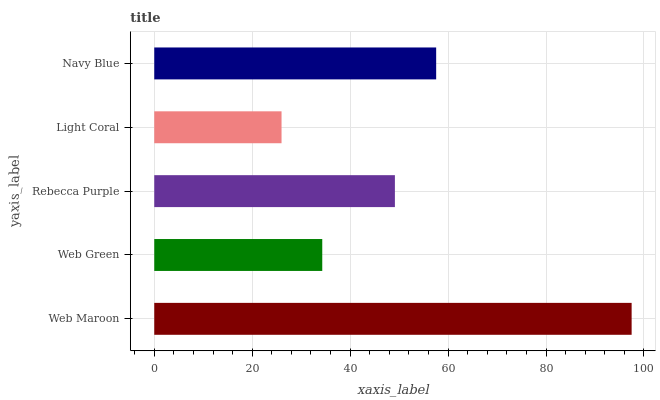Is Light Coral the minimum?
Answer yes or no. Yes. Is Web Maroon the maximum?
Answer yes or no. Yes. Is Web Green the minimum?
Answer yes or no. No. Is Web Green the maximum?
Answer yes or no. No. Is Web Maroon greater than Web Green?
Answer yes or no. Yes. Is Web Green less than Web Maroon?
Answer yes or no. Yes. Is Web Green greater than Web Maroon?
Answer yes or no. No. Is Web Maroon less than Web Green?
Answer yes or no. No. Is Rebecca Purple the high median?
Answer yes or no. Yes. Is Rebecca Purple the low median?
Answer yes or no. Yes. Is Web Green the high median?
Answer yes or no. No. Is Navy Blue the low median?
Answer yes or no. No. 